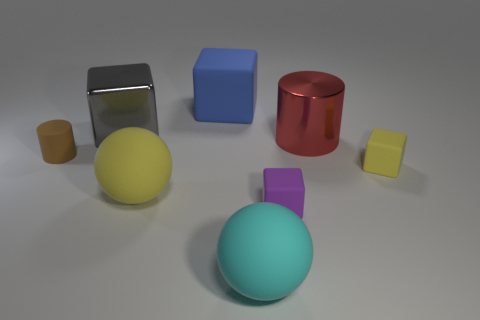Can you describe the lighting and shadows in the scene? The lighting in the scene appears to be diffused with a softbox light source coming from the top right, as indicated by the soft-edged shadows cast to the left of the objects. The intensity of the light is moderate, not causing harsh reflections on the surfaces except for the shiny metal object, which shows a bright specular highlight. 